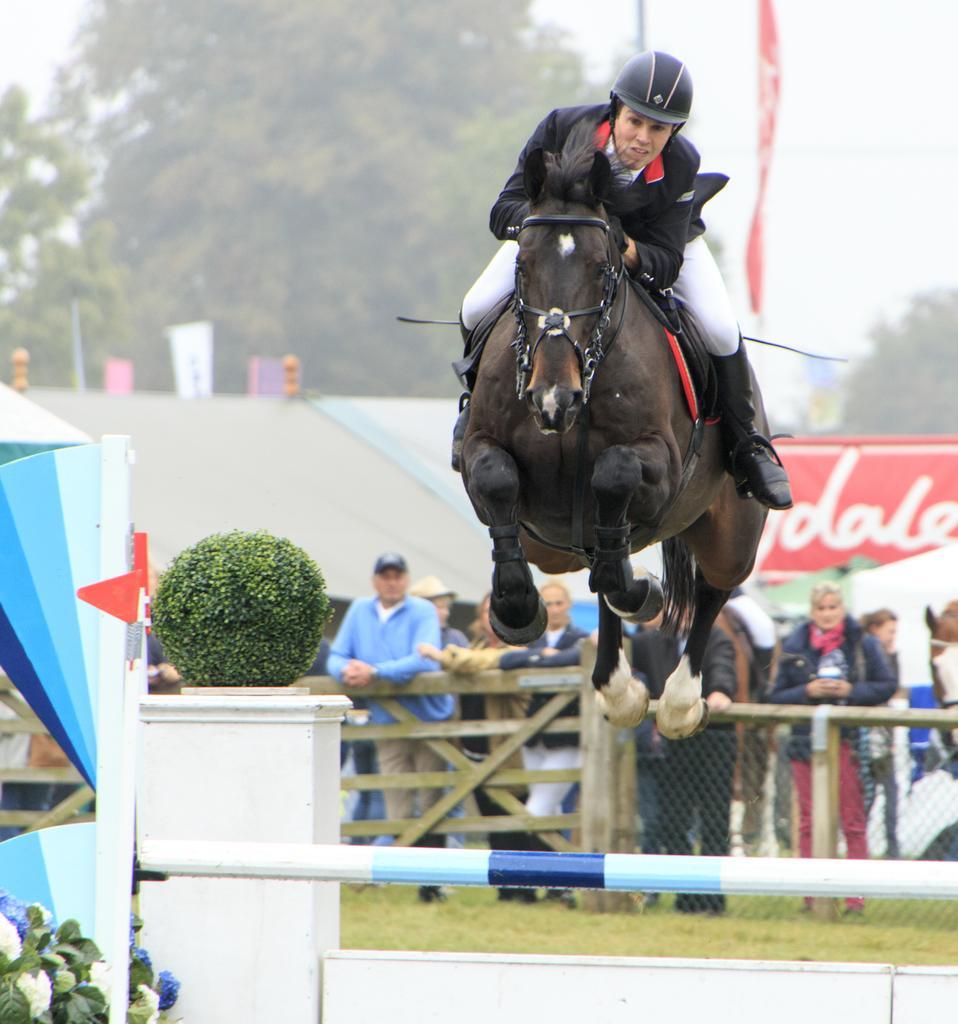Could you give a brief overview of what you see in this image? In this picture we can see person wore helmet sitting on horse where it is crossing the pole and in background we can see some persons standing at fence and looking at this horse, wall, banner, tree, sky, plant on pillar. 